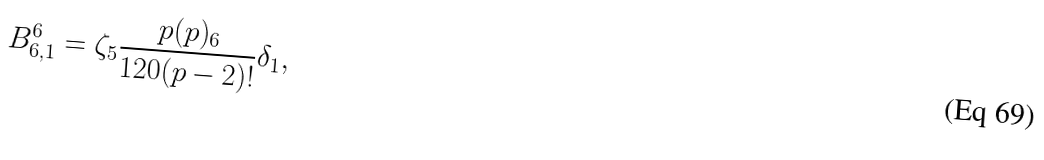Convert formula to latex. <formula><loc_0><loc_0><loc_500><loc_500>B ^ { 6 } _ { 6 , 1 } = \zeta _ { 5 } \frac { p ( p ) _ { 6 } } { 1 2 0 ( p - 2 ) ! } \delta _ { 1 } ,</formula> 